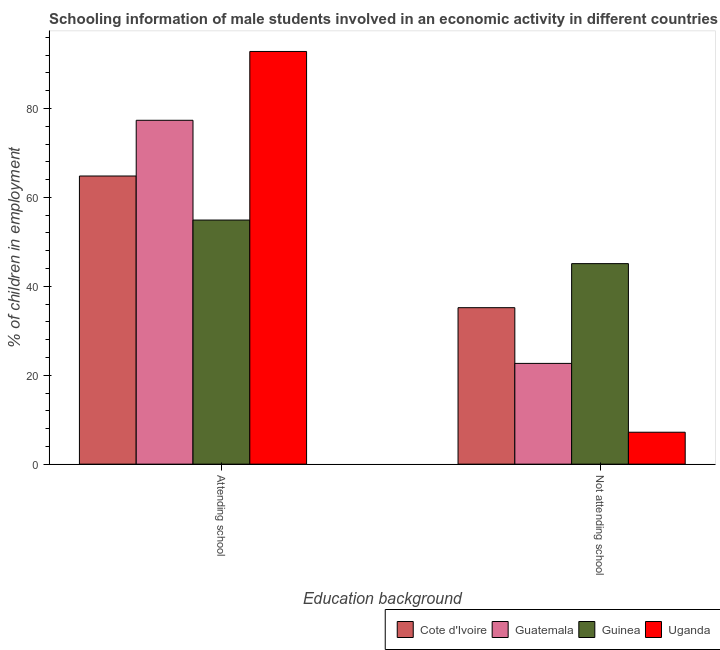How many bars are there on the 1st tick from the left?
Your answer should be very brief. 4. What is the label of the 1st group of bars from the left?
Provide a succinct answer. Attending school. What is the percentage of employed males who are attending school in Guatemala?
Offer a very short reply. 77.34. Across all countries, what is the maximum percentage of employed males who are not attending school?
Make the answer very short. 45.1. Across all countries, what is the minimum percentage of employed males who are not attending school?
Your response must be concise. 7.18. In which country was the percentage of employed males who are attending school maximum?
Offer a very short reply. Uganda. In which country was the percentage of employed males who are attending school minimum?
Give a very brief answer. Guinea. What is the total percentage of employed males who are attending school in the graph?
Ensure brevity in your answer.  289.87. What is the difference between the percentage of employed males who are not attending school in Cote d'Ivoire and that in Guatemala?
Make the answer very short. 12.53. What is the difference between the percentage of employed males who are not attending school in Uganda and the percentage of employed males who are attending school in Guinea?
Provide a short and direct response. -47.72. What is the average percentage of employed males who are not attending school per country?
Provide a succinct answer. 27.53. What is the difference between the percentage of employed males who are not attending school and percentage of employed males who are attending school in Guinea?
Keep it short and to the point. -9.8. In how many countries, is the percentage of employed males who are attending school greater than 20 %?
Your answer should be very brief. 4. What is the ratio of the percentage of employed males who are not attending school in Uganda to that in Guatemala?
Give a very brief answer. 0.32. Is the percentage of employed males who are attending school in Guinea less than that in Uganda?
Your response must be concise. Yes. What does the 1st bar from the left in Not attending school represents?
Make the answer very short. Cote d'Ivoire. What does the 3rd bar from the right in Not attending school represents?
Offer a very short reply. Guatemala. Are all the bars in the graph horizontal?
Provide a short and direct response. No. How many countries are there in the graph?
Ensure brevity in your answer.  4. What is the difference between two consecutive major ticks on the Y-axis?
Your response must be concise. 20. Are the values on the major ticks of Y-axis written in scientific E-notation?
Provide a succinct answer. No. Does the graph contain any zero values?
Your answer should be compact. No. Where does the legend appear in the graph?
Make the answer very short. Bottom right. How many legend labels are there?
Your response must be concise. 4. What is the title of the graph?
Your answer should be compact. Schooling information of male students involved in an economic activity in different countries. Does "Romania" appear as one of the legend labels in the graph?
Ensure brevity in your answer.  No. What is the label or title of the X-axis?
Provide a succinct answer. Education background. What is the label or title of the Y-axis?
Keep it short and to the point. % of children in employment. What is the % of children in employment of Cote d'Ivoire in Attending school?
Your response must be concise. 64.81. What is the % of children in employment of Guatemala in Attending school?
Give a very brief answer. 77.34. What is the % of children in employment in Guinea in Attending school?
Give a very brief answer. 54.9. What is the % of children in employment in Uganda in Attending school?
Offer a terse response. 92.82. What is the % of children in employment in Cote d'Ivoire in Not attending school?
Provide a succinct answer. 35.19. What is the % of children in employment in Guatemala in Not attending school?
Offer a terse response. 22.66. What is the % of children in employment of Guinea in Not attending school?
Provide a succinct answer. 45.1. What is the % of children in employment in Uganda in Not attending school?
Provide a succinct answer. 7.18. Across all Education background, what is the maximum % of children in employment in Cote d'Ivoire?
Offer a terse response. 64.81. Across all Education background, what is the maximum % of children in employment of Guatemala?
Offer a terse response. 77.34. Across all Education background, what is the maximum % of children in employment in Guinea?
Offer a very short reply. 54.9. Across all Education background, what is the maximum % of children in employment of Uganda?
Give a very brief answer. 92.82. Across all Education background, what is the minimum % of children in employment in Cote d'Ivoire?
Provide a succinct answer. 35.19. Across all Education background, what is the minimum % of children in employment of Guatemala?
Your answer should be compact. 22.66. Across all Education background, what is the minimum % of children in employment in Guinea?
Provide a succinct answer. 45.1. Across all Education background, what is the minimum % of children in employment of Uganda?
Offer a very short reply. 7.18. What is the total % of children in employment in Cote d'Ivoire in the graph?
Ensure brevity in your answer.  100. What is the total % of children in employment of Guatemala in the graph?
Offer a very short reply. 100. What is the total % of children in employment in Guinea in the graph?
Provide a succinct answer. 100. What is the difference between the % of children in employment of Cote d'Ivoire in Attending school and that in Not attending school?
Provide a succinct answer. 29.62. What is the difference between the % of children in employment in Guatemala in Attending school and that in Not attending school?
Provide a succinct answer. 54.68. What is the difference between the % of children in employment of Guinea in Attending school and that in Not attending school?
Offer a terse response. 9.8. What is the difference between the % of children in employment of Uganda in Attending school and that in Not attending school?
Offer a very short reply. 85.64. What is the difference between the % of children in employment in Cote d'Ivoire in Attending school and the % of children in employment in Guatemala in Not attending school?
Provide a succinct answer. 42.15. What is the difference between the % of children in employment in Cote d'Ivoire in Attending school and the % of children in employment in Guinea in Not attending school?
Ensure brevity in your answer.  19.71. What is the difference between the % of children in employment in Cote d'Ivoire in Attending school and the % of children in employment in Uganda in Not attending school?
Ensure brevity in your answer.  57.63. What is the difference between the % of children in employment in Guatemala in Attending school and the % of children in employment in Guinea in Not attending school?
Offer a terse response. 32.24. What is the difference between the % of children in employment of Guatemala in Attending school and the % of children in employment of Uganda in Not attending school?
Give a very brief answer. 70.16. What is the difference between the % of children in employment of Guinea in Attending school and the % of children in employment of Uganda in Not attending school?
Provide a short and direct response. 47.72. What is the average % of children in employment of Guatemala per Education background?
Ensure brevity in your answer.  50. What is the difference between the % of children in employment of Cote d'Ivoire and % of children in employment of Guatemala in Attending school?
Provide a short and direct response. -12.53. What is the difference between the % of children in employment of Cote d'Ivoire and % of children in employment of Guinea in Attending school?
Make the answer very short. 9.91. What is the difference between the % of children in employment of Cote d'Ivoire and % of children in employment of Uganda in Attending school?
Your response must be concise. -28.01. What is the difference between the % of children in employment of Guatemala and % of children in employment of Guinea in Attending school?
Your answer should be compact. 22.44. What is the difference between the % of children in employment of Guatemala and % of children in employment of Uganda in Attending school?
Provide a short and direct response. -15.48. What is the difference between the % of children in employment in Guinea and % of children in employment in Uganda in Attending school?
Provide a short and direct response. -37.92. What is the difference between the % of children in employment of Cote d'Ivoire and % of children in employment of Guatemala in Not attending school?
Provide a short and direct response. 12.53. What is the difference between the % of children in employment of Cote d'Ivoire and % of children in employment of Guinea in Not attending school?
Your response must be concise. -9.91. What is the difference between the % of children in employment in Cote d'Ivoire and % of children in employment in Uganda in Not attending school?
Provide a short and direct response. 28.01. What is the difference between the % of children in employment of Guatemala and % of children in employment of Guinea in Not attending school?
Offer a very short reply. -22.44. What is the difference between the % of children in employment in Guatemala and % of children in employment in Uganda in Not attending school?
Keep it short and to the point. 15.48. What is the difference between the % of children in employment in Guinea and % of children in employment in Uganda in Not attending school?
Offer a terse response. 37.92. What is the ratio of the % of children in employment of Cote d'Ivoire in Attending school to that in Not attending school?
Your answer should be compact. 1.84. What is the ratio of the % of children in employment of Guatemala in Attending school to that in Not attending school?
Keep it short and to the point. 3.41. What is the ratio of the % of children in employment in Guinea in Attending school to that in Not attending school?
Keep it short and to the point. 1.22. What is the ratio of the % of children in employment in Uganda in Attending school to that in Not attending school?
Offer a very short reply. 12.93. What is the difference between the highest and the second highest % of children in employment of Cote d'Ivoire?
Your response must be concise. 29.62. What is the difference between the highest and the second highest % of children in employment in Guatemala?
Provide a succinct answer. 54.68. What is the difference between the highest and the second highest % of children in employment in Guinea?
Your response must be concise. 9.8. What is the difference between the highest and the second highest % of children in employment in Uganda?
Ensure brevity in your answer.  85.64. What is the difference between the highest and the lowest % of children in employment of Cote d'Ivoire?
Give a very brief answer. 29.62. What is the difference between the highest and the lowest % of children in employment in Guatemala?
Make the answer very short. 54.68. What is the difference between the highest and the lowest % of children in employment of Uganda?
Make the answer very short. 85.64. 